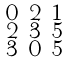<formula> <loc_0><loc_0><loc_500><loc_500>\begin{smallmatrix} 0 & 2 & 1 \\ 2 & 3 & 5 \\ 3 & 0 & 5 \end{smallmatrix}</formula> 